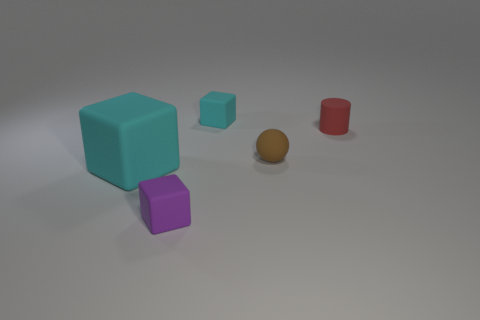There is a cyan block that is behind the big cyan object; are there any purple blocks behind it?
Give a very brief answer. No. There is a small rubber ball; does it have the same color as the cube that is behind the brown rubber sphere?
Give a very brief answer. No. Is there a big block made of the same material as the tiny cyan thing?
Offer a terse response. Yes. What number of tiny red metallic things are there?
Give a very brief answer. 0. There is a cyan object that is on the right side of the cyan cube in front of the small cyan matte cube; what is it made of?
Provide a short and direct response. Rubber. There is a large thing that is made of the same material as the cylinder; what color is it?
Provide a succinct answer. Cyan. There is a object that is the same color as the large matte block; what shape is it?
Keep it short and to the point. Cube. Does the cyan object that is behind the tiny cylinder have the same size as the purple rubber block on the left side of the tiny brown rubber sphere?
Provide a succinct answer. Yes. What number of cylinders are either small brown matte things or purple things?
Your answer should be very brief. 0. Is the cyan thing that is behind the large object made of the same material as the tiny purple thing?
Give a very brief answer. Yes. 